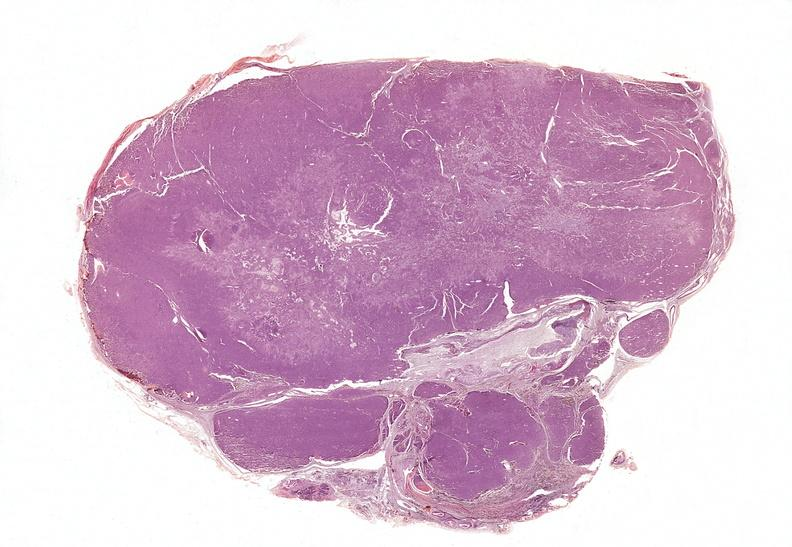s endocrine present?
Answer the question using a single word or phrase. Yes 